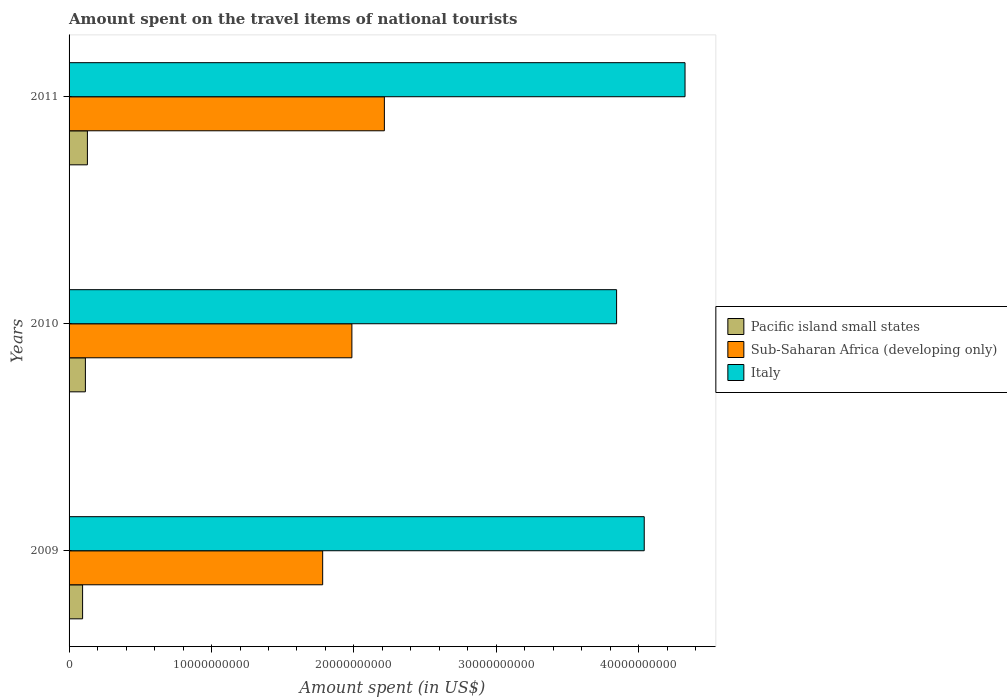How many different coloured bars are there?
Ensure brevity in your answer.  3. How many groups of bars are there?
Your answer should be compact. 3. How many bars are there on the 3rd tick from the top?
Your response must be concise. 3. How many bars are there on the 1st tick from the bottom?
Your response must be concise. 3. What is the label of the 2nd group of bars from the top?
Offer a terse response. 2010. In how many cases, is the number of bars for a given year not equal to the number of legend labels?
Provide a succinct answer. 0. What is the amount spent on the travel items of national tourists in Italy in 2011?
Your response must be concise. 4.32e+1. Across all years, what is the maximum amount spent on the travel items of national tourists in Italy?
Your answer should be very brief. 4.32e+1. Across all years, what is the minimum amount spent on the travel items of national tourists in Italy?
Provide a short and direct response. 3.84e+1. What is the total amount spent on the travel items of national tourists in Sub-Saharan Africa (developing only) in the graph?
Give a very brief answer. 5.98e+1. What is the difference between the amount spent on the travel items of national tourists in Sub-Saharan Africa (developing only) in 2010 and that in 2011?
Your answer should be very brief. -2.28e+09. What is the difference between the amount spent on the travel items of national tourists in Italy in 2010 and the amount spent on the travel items of national tourists in Pacific island small states in 2011?
Keep it short and to the point. 3.72e+1. What is the average amount spent on the travel items of national tourists in Italy per year?
Your answer should be very brief. 4.07e+1. In the year 2009, what is the difference between the amount spent on the travel items of national tourists in Italy and amount spent on the travel items of national tourists in Pacific island small states?
Your answer should be very brief. 3.94e+1. In how many years, is the amount spent on the travel items of national tourists in Italy greater than 18000000000 US$?
Ensure brevity in your answer.  3. What is the ratio of the amount spent on the travel items of national tourists in Italy in 2010 to that in 2011?
Your response must be concise. 0.89. Is the amount spent on the travel items of national tourists in Pacific island small states in 2010 less than that in 2011?
Provide a succinct answer. Yes. Is the difference between the amount spent on the travel items of national tourists in Italy in 2010 and 2011 greater than the difference between the amount spent on the travel items of national tourists in Pacific island small states in 2010 and 2011?
Keep it short and to the point. No. What is the difference between the highest and the second highest amount spent on the travel items of national tourists in Italy?
Keep it short and to the point. 2.86e+09. What is the difference between the highest and the lowest amount spent on the travel items of national tourists in Pacific island small states?
Offer a very short reply. 3.38e+08. What does the 2nd bar from the top in 2009 represents?
Offer a terse response. Sub-Saharan Africa (developing only). What does the 2nd bar from the bottom in 2011 represents?
Your answer should be very brief. Sub-Saharan Africa (developing only). Are all the bars in the graph horizontal?
Your response must be concise. Yes. What is the difference between two consecutive major ticks on the X-axis?
Your response must be concise. 1.00e+1. How many legend labels are there?
Offer a very short reply. 3. How are the legend labels stacked?
Your answer should be compact. Vertical. What is the title of the graph?
Your answer should be very brief. Amount spent on the travel items of national tourists. What is the label or title of the X-axis?
Provide a short and direct response. Amount spent (in US$). What is the Amount spent (in US$) of Pacific island small states in 2009?
Give a very brief answer. 9.49e+08. What is the Amount spent (in US$) of Sub-Saharan Africa (developing only) in 2009?
Make the answer very short. 1.78e+1. What is the Amount spent (in US$) of Italy in 2009?
Keep it short and to the point. 4.04e+1. What is the Amount spent (in US$) in Pacific island small states in 2010?
Ensure brevity in your answer.  1.15e+09. What is the Amount spent (in US$) in Sub-Saharan Africa (developing only) in 2010?
Make the answer very short. 1.99e+1. What is the Amount spent (in US$) in Italy in 2010?
Your answer should be very brief. 3.84e+1. What is the Amount spent (in US$) of Pacific island small states in 2011?
Ensure brevity in your answer.  1.29e+09. What is the Amount spent (in US$) in Sub-Saharan Africa (developing only) in 2011?
Keep it short and to the point. 2.21e+1. What is the Amount spent (in US$) of Italy in 2011?
Provide a succinct answer. 4.32e+1. Across all years, what is the maximum Amount spent (in US$) of Pacific island small states?
Ensure brevity in your answer.  1.29e+09. Across all years, what is the maximum Amount spent (in US$) in Sub-Saharan Africa (developing only)?
Ensure brevity in your answer.  2.21e+1. Across all years, what is the maximum Amount spent (in US$) in Italy?
Make the answer very short. 4.32e+1. Across all years, what is the minimum Amount spent (in US$) of Pacific island small states?
Your answer should be compact. 9.49e+08. Across all years, what is the minimum Amount spent (in US$) of Sub-Saharan Africa (developing only)?
Ensure brevity in your answer.  1.78e+1. Across all years, what is the minimum Amount spent (in US$) in Italy?
Make the answer very short. 3.84e+1. What is the total Amount spent (in US$) of Pacific island small states in the graph?
Offer a very short reply. 3.38e+09. What is the total Amount spent (in US$) in Sub-Saharan Africa (developing only) in the graph?
Make the answer very short. 5.98e+1. What is the total Amount spent (in US$) of Italy in the graph?
Keep it short and to the point. 1.22e+11. What is the difference between the Amount spent (in US$) of Pacific island small states in 2009 and that in 2010?
Your answer should be compact. -1.96e+08. What is the difference between the Amount spent (in US$) in Sub-Saharan Africa (developing only) in 2009 and that in 2010?
Offer a very short reply. -2.05e+09. What is the difference between the Amount spent (in US$) in Italy in 2009 and that in 2010?
Keep it short and to the point. 1.94e+09. What is the difference between the Amount spent (in US$) of Pacific island small states in 2009 and that in 2011?
Ensure brevity in your answer.  -3.38e+08. What is the difference between the Amount spent (in US$) of Sub-Saharan Africa (developing only) in 2009 and that in 2011?
Offer a terse response. -4.33e+09. What is the difference between the Amount spent (in US$) in Italy in 2009 and that in 2011?
Give a very brief answer. -2.86e+09. What is the difference between the Amount spent (in US$) in Pacific island small states in 2010 and that in 2011?
Provide a succinct answer. -1.42e+08. What is the difference between the Amount spent (in US$) of Sub-Saharan Africa (developing only) in 2010 and that in 2011?
Your answer should be very brief. -2.28e+09. What is the difference between the Amount spent (in US$) of Italy in 2010 and that in 2011?
Offer a very short reply. -4.80e+09. What is the difference between the Amount spent (in US$) in Pacific island small states in 2009 and the Amount spent (in US$) in Sub-Saharan Africa (developing only) in 2010?
Give a very brief answer. -1.89e+1. What is the difference between the Amount spent (in US$) in Pacific island small states in 2009 and the Amount spent (in US$) in Italy in 2010?
Offer a very short reply. -3.75e+1. What is the difference between the Amount spent (in US$) of Sub-Saharan Africa (developing only) in 2009 and the Amount spent (in US$) of Italy in 2010?
Provide a succinct answer. -2.06e+1. What is the difference between the Amount spent (in US$) in Pacific island small states in 2009 and the Amount spent (in US$) in Sub-Saharan Africa (developing only) in 2011?
Offer a very short reply. -2.12e+1. What is the difference between the Amount spent (in US$) of Pacific island small states in 2009 and the Amount spent (in US$) of Italy in 2011?
Make the answer very short. -4.23e+1. What is the difference between the Amount spent (in US$) in Sub-Saharan Africa (developing only) in 2009 and the Amount spent (in US$) in Italy in 2011?
Offer a terse response. -2.54e+1. What is the difference between the Amount spent (in US$) of Pacific island small states in 2010 and the Amount spent (in US$) of Sub-Saharan Africa (developing only) in 2011?
Provide a short and direct response. -2.10e+1. What is the difference between the Amount spent (in US$) in Pacific island small states in 2010 and the Amount spent (in US$) in Italy in 2011?
Make the answer very short. -4.21e+1. What is the difference between the Amount spent (in US$) of Sub-Saharan Africa (developing only) in 2010 and the Amount spent (in US$) of Italy in 2011?
Your answer should be compact. -2.34e+1. What is the average Amount spent (in US$) of Pacific island small states per year?
Provide a short and direct response. 1.13e+09. What is the average Amount spent (in US$) of Sub-Saharan Africa (developing only) per year?
Your response must be concise. 1.99e+1. What is the average Amount spent (in US$) of Italy per year?
Provide a succinct answer. 4.07e+1. In the year 2009, what is the difference between the Amount spent (in US$) in Pacific island small states and Amount spent (in US$) in Sub-Saharan Africa (developing only)?
Provide a succinct answer. -1.69e+1. In the year 2009, what is the difference between the Amount spent (in US$) in Pacific island small states and Amount spent (in US$) in Italy?
Make the answer very short. -3.94e+1. In the year 2009, what is the difference between the Amount spent (in US$) in Sub-Saharan Africa (developing only) and Amount spent (in US$) in Italy?
Make the answer very short. -2.26e+1. In the year 2010, what is the difference between the Amount spent (in US$) of Pacific island small states and Amount spent (in US$) of Sub-Saharan Africa (developing only)?
Your response must be concise. -1.87e+1. In the year 2010, what is the difference between the Amount spent (in US$) in Pacific island small states and Amount spent (in US$) in Italy?
Keep it short and to the point. -3.73e+1. In the year 2010, what is the difference between the Amount spent (in US$) in Sub-Saharan Africa (developing only) and Amount spent (in US$) in Italy?
Provide a succinct answer. -1.86e+1. In the year 2011, what is the difference between the Amount spent (in US$) in Pacific island small states and Amount spent (in US$) in Sub-Saharan Africa (developing only)?
Keep it short and to the point. -2.08e+1. In the year 2011, what is the difference between the Amount spent (in US$) of Pacific island small states and Amount spent (in US$) of Italy?
Ensure brevity in your answer.  -4.20e+1. In the year 2011, what is the difference between the Amount spent (in US$) in Sub-Saharan Africa (developing only) and Amount spent (in US$) in Italy?
Provide a short and direct response. -2.11e+1. What is the ratio of the Amount spent (in US$) in Pacific island small states in 2009 to that in 2010?
Make the answer very short. 0.83. What is the ratio of the Amount spent (in US$) of Sub-Saharan Africa (developing only) in 2009 to that in 2010?
Your answer should be very brief. 0.9. What is the ratio of the Amount spent (in US$) of Italy in 2009 to that in 2010?
Give a very brief answer. 1.05. What is the ratio of the Amount spent (in US$) in Pacific island small states in 2009 to that in 2011?
Your answer should be compact. 0.74. What is the ratio of the Amount spent (in US$) in Sub-Saharan Africa (developing only) in 2009 to that in 2011?
Your answer should be compact. 0.8. What is the ratio of the Amount spent (in US$) of Italy in 2009 to that in 2011?
Make the answer very short. 0.93. What is the ratio of the Amount spent (in US$) in Pacific island small states in 2010 to that in 2011?
Offer a terse response. 0.89. What is the ratio of the Amount spent (in US$) in Sub-Saharan Africa (developing only) in 2010 to that in 2011?
Offer a very short reply. 0.9. What is the ratio of the Amount spent (in US$) of Italy in 2010 to that in 2011?
Offer a very short reply. 0.89. What is the difference between the highest and the second highest Amount spent (in US$) of Pacific island small states?
Your answer should be very brief. 1.42e+08. What is the difference between the highest and the second highest Amount spent (in US$) of Sub-Saharan Africa (developing only)?
Ensure brevity in your answer.  2.28e+09. What is the difference between the highest and the second highest Amount spent (in US$) in Italy?
Give a very brief answer. 2.86e+09. What is the difference between the highest and the lowest Amount spent (in US$) in Pacific island small states?
Give a very brief answer. 3.38e+08. What is the difference between the highest and the lowest Amount spent (in US$) of Sub-Saharan Africa (developing only)?
Provide a succinct answer. 4.33e+09. What is the difference between the highest and the lowest Amount spent (in US$) of Italy?
Make the answer very short. 4.80e+09. 